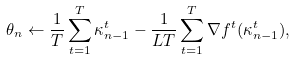<formula> <loc_0><loc_0><loc_500><loc_500>\theta _ { n } \leftarrow \frac { 1 } { T } \sum _ { t = 1 } ^ { T } \kappa _ { n - 1 } ^ { t } - \frac { 1 } { L T } \sum _ { t = 1 } ^ { T } \nabla f ^ { t } ( \kappa _ { n - 1 } ^ { t } ) ,</formula> 